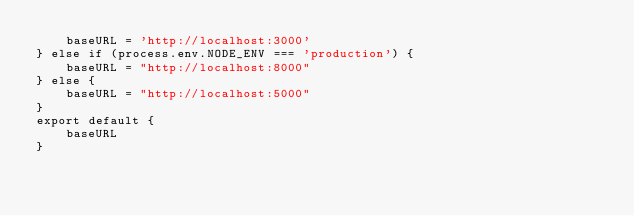Convert code to text. <code><loc_0><loc_0><loc_500><loc_500><_JavaScript_>    baseURL = 'http://localhost:3000'
} else if (process.env.NODE_ENV === 'production') {
    baseURL = "http://localhost:8000"
} else {
    baseURL = "http://localhost:5000"
}
export default {
    baseURL
}
</code> 